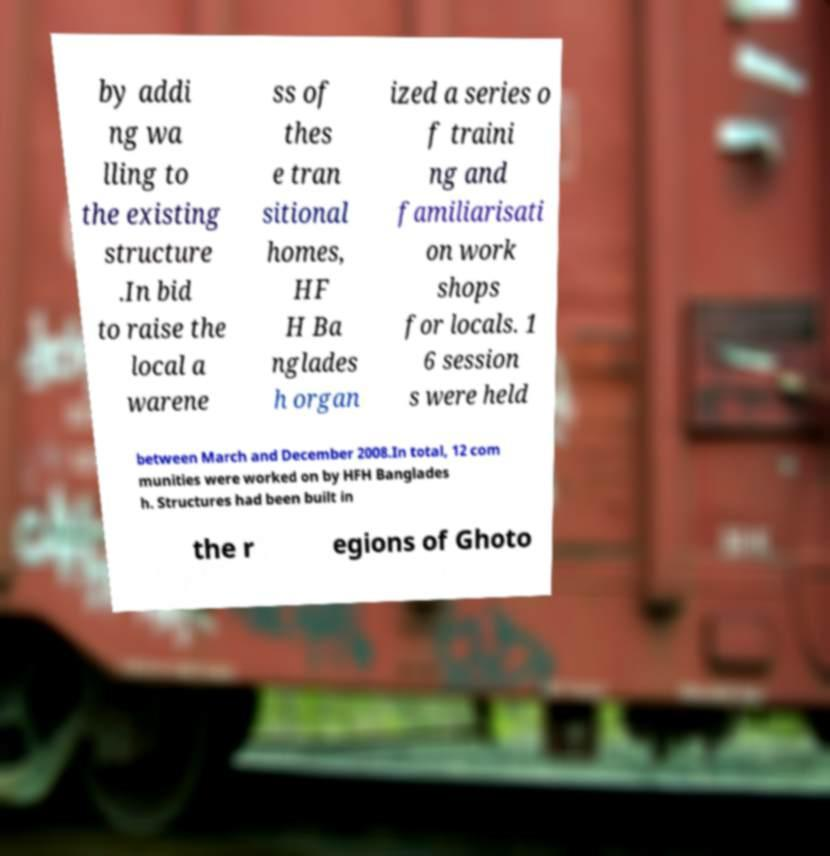For documentation purposes, I need the text within this image transcribed. Could you provide that? by addi ng wa lling to the existing structure .In bid to raise the local a warene ss of thes e tran sitional homes, HF H Ba nglades h organ ized a series o f traini ng and familiarisati on work shops for locals. 1 6 session s were held between March and December 2008.In total, 12 com munities were worked on by HFH Banglades h. Structures had been built in the r egions of Ghoto 